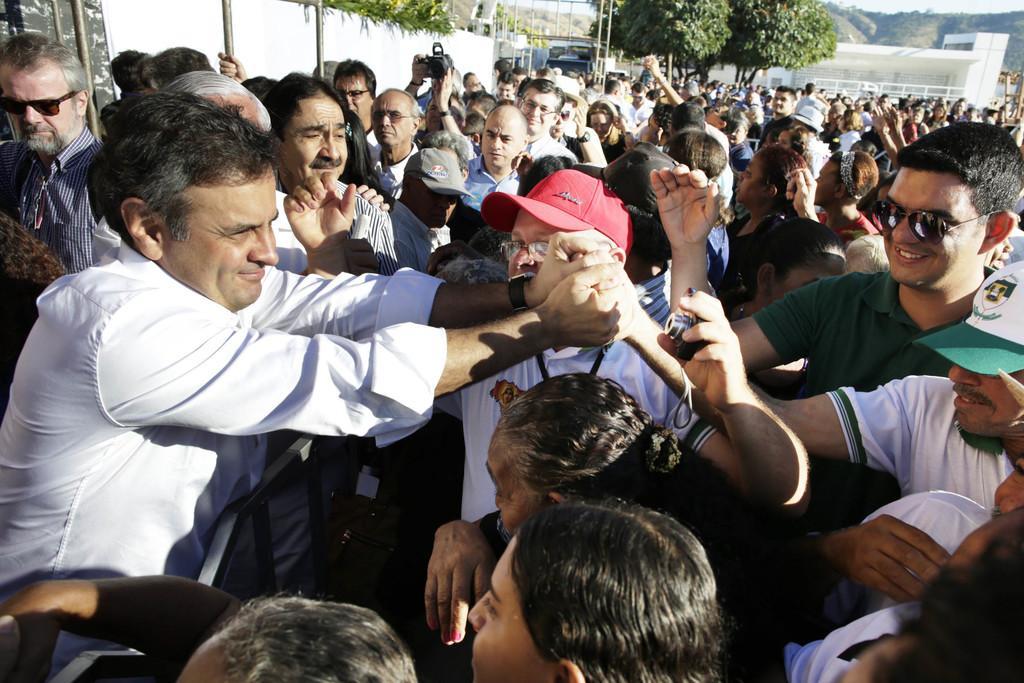In one or two sentences, can you explain what this image depicts? In this image we can see people standing on the road and some of them are holding cameras in their hands. In the background there are poles, trees, wells, hills and sky. 